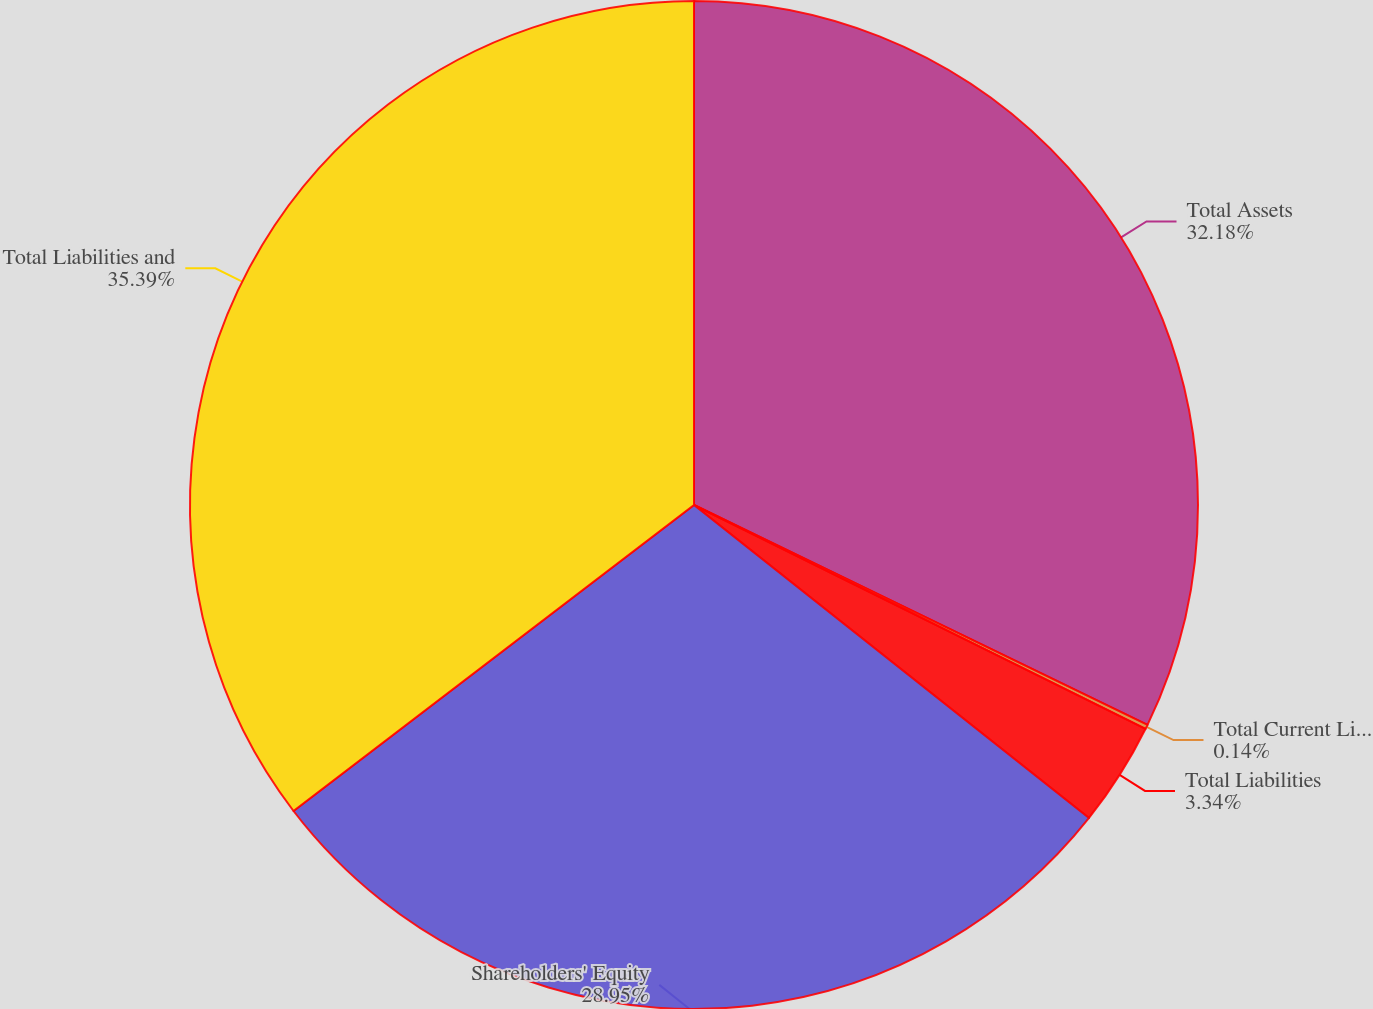Convert chart to OTSL. <chart><loc_0><loc_0><loc_500><loc_500><pie_chart><fcel>Total Assets<fcel>Total Current Liabilities<fcel>Total Liabilities<fcel>Shareholders' Equity<fcel>Total Liabilities and<nl><fcel>32.18%<fcel>0.14%<fcel>3.34%<fcel>28.95%<fcel>35.38%<nl></chart> 